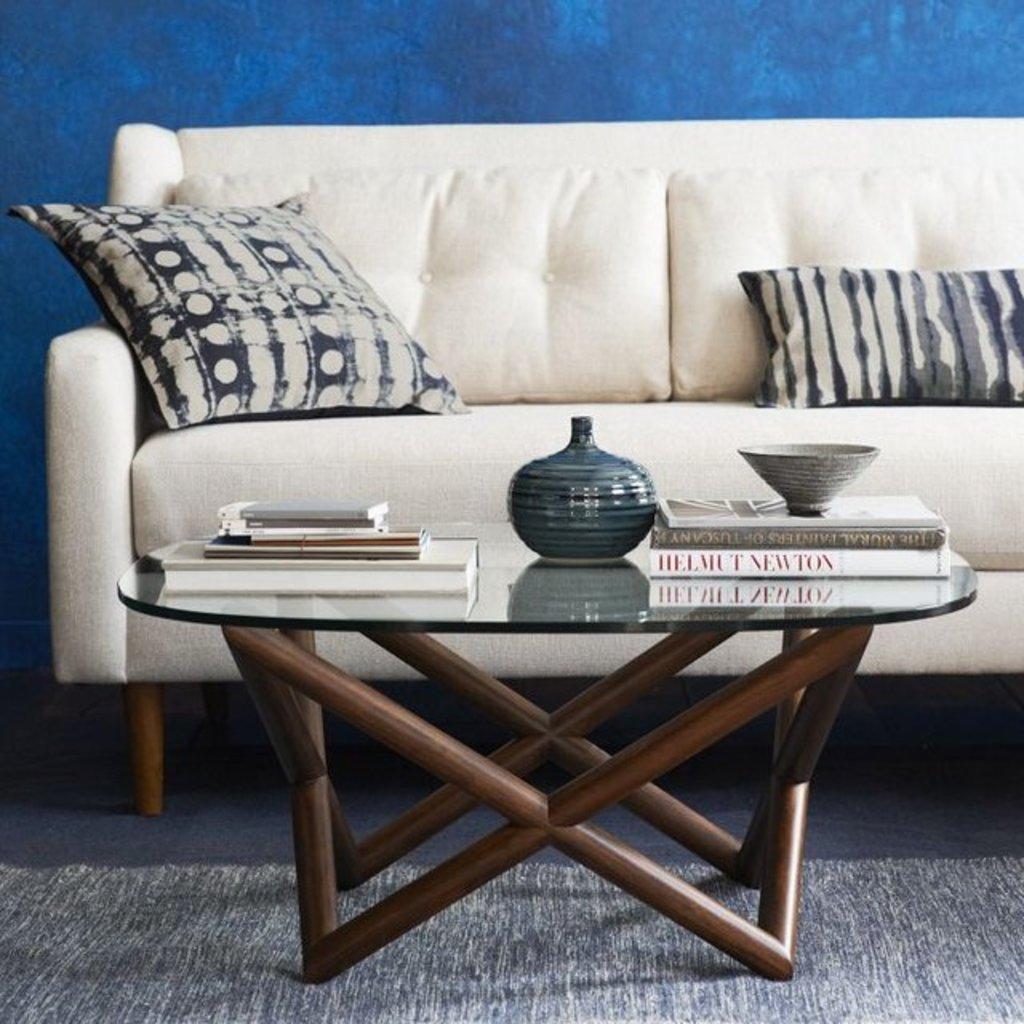Could you give a brief overview of what you see in this image? In this picture we can able to see a table, on this table there are books, bowl and vase. In-front of this table there is a couch with pillow. The wall is in blue color. A floor with carpet. 